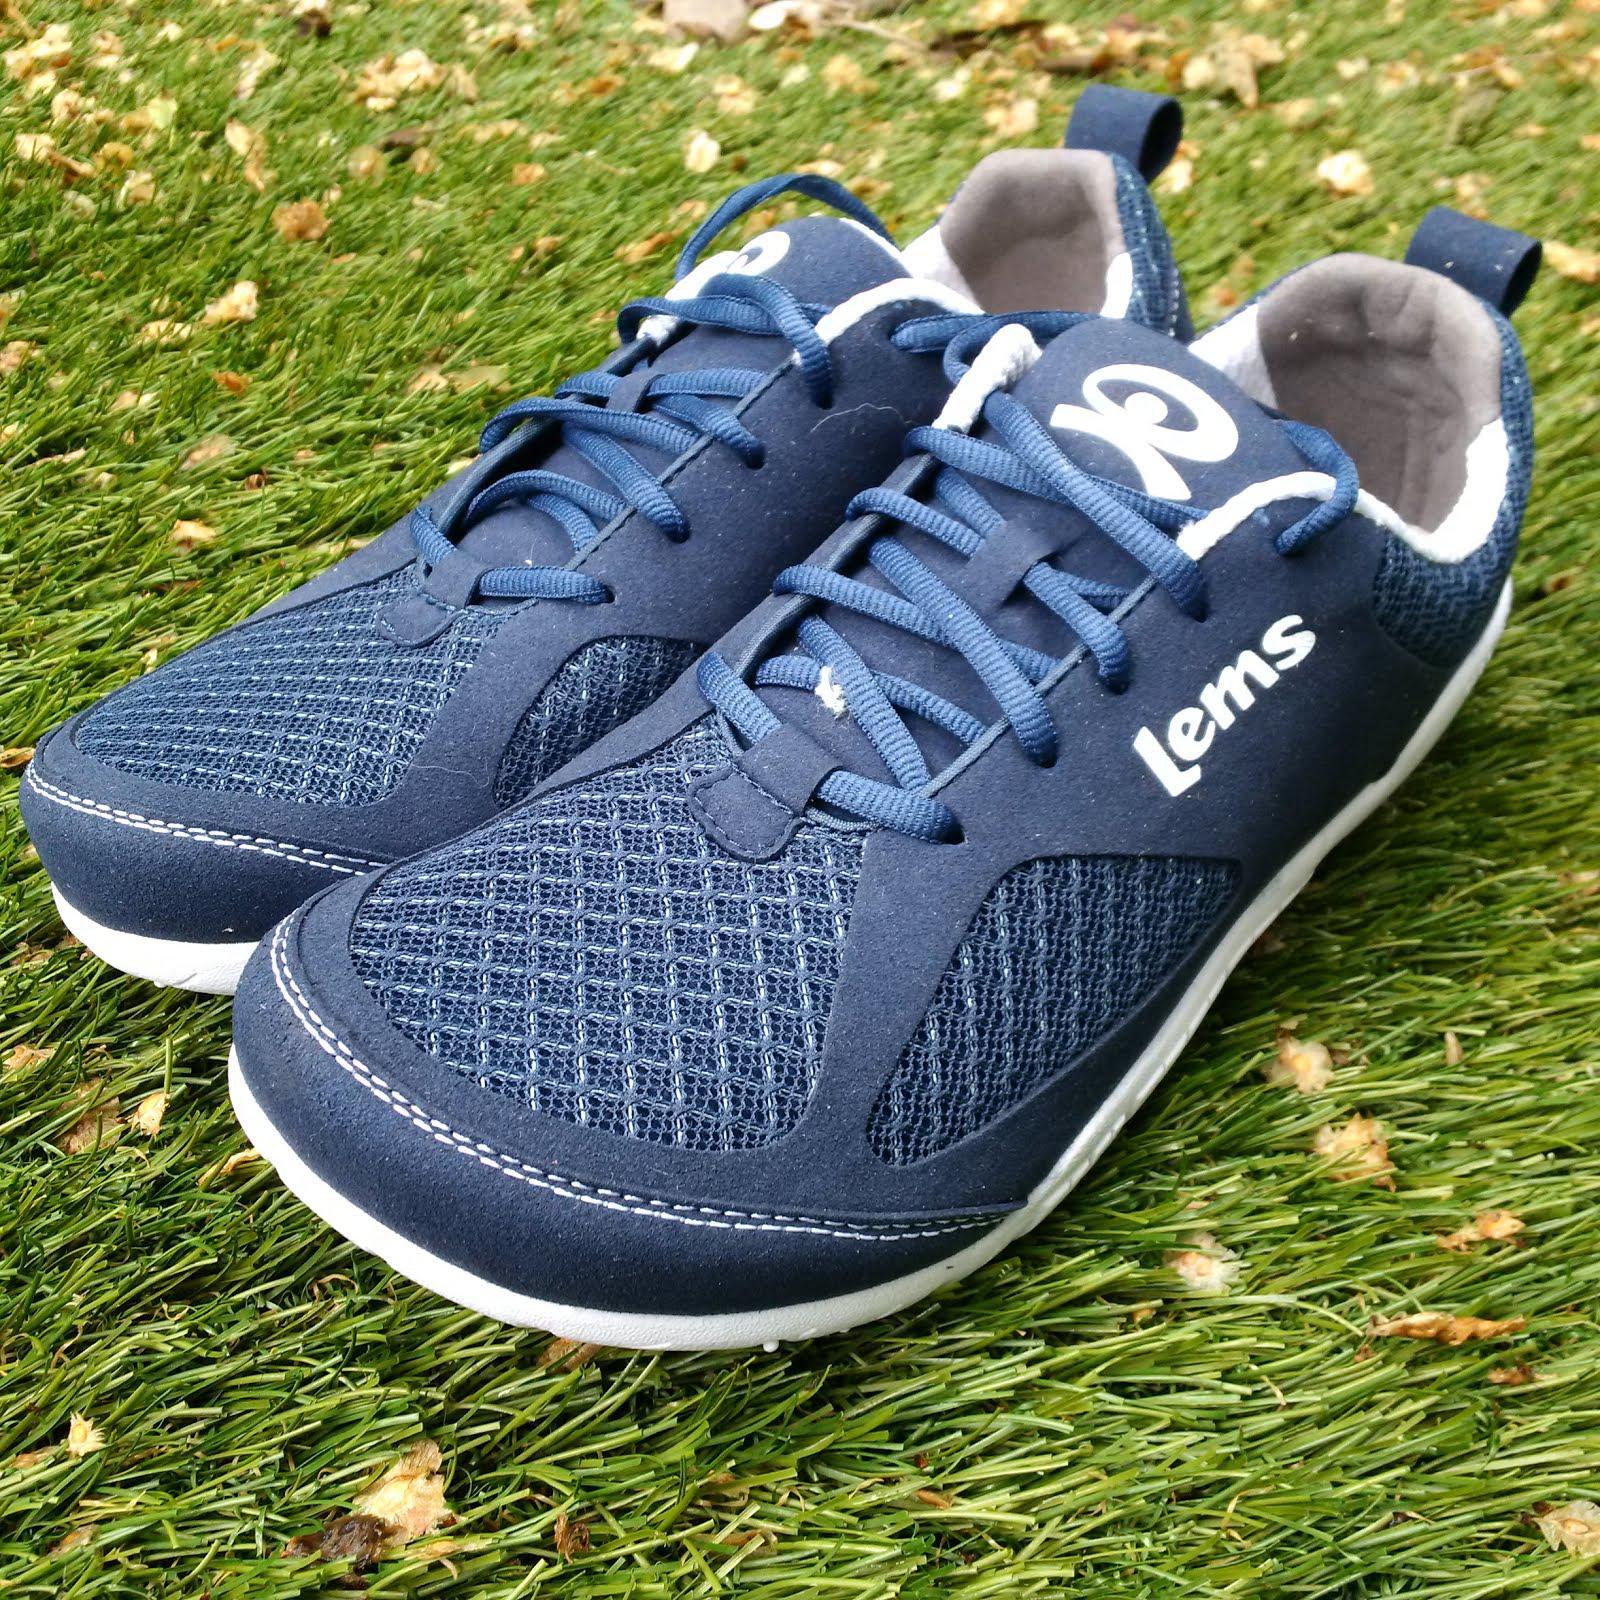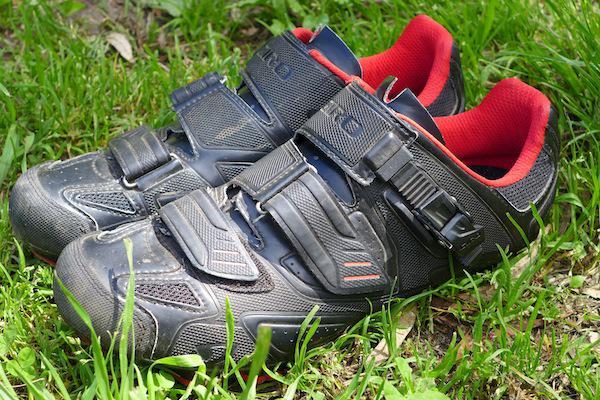The first image is the image on the left, the second image is the image on the right. Given the left and right images, does the statement "there are at most2 pair of shoes per image pair" hold true? Answer yes or no. Yes. The first image is the image on the left, the second image is the image on the right. Analyze the images presented: Is the assertion "There is a pair of athletic shoes sitting outside in the grass." valid? Answer yes or no. Yes. 